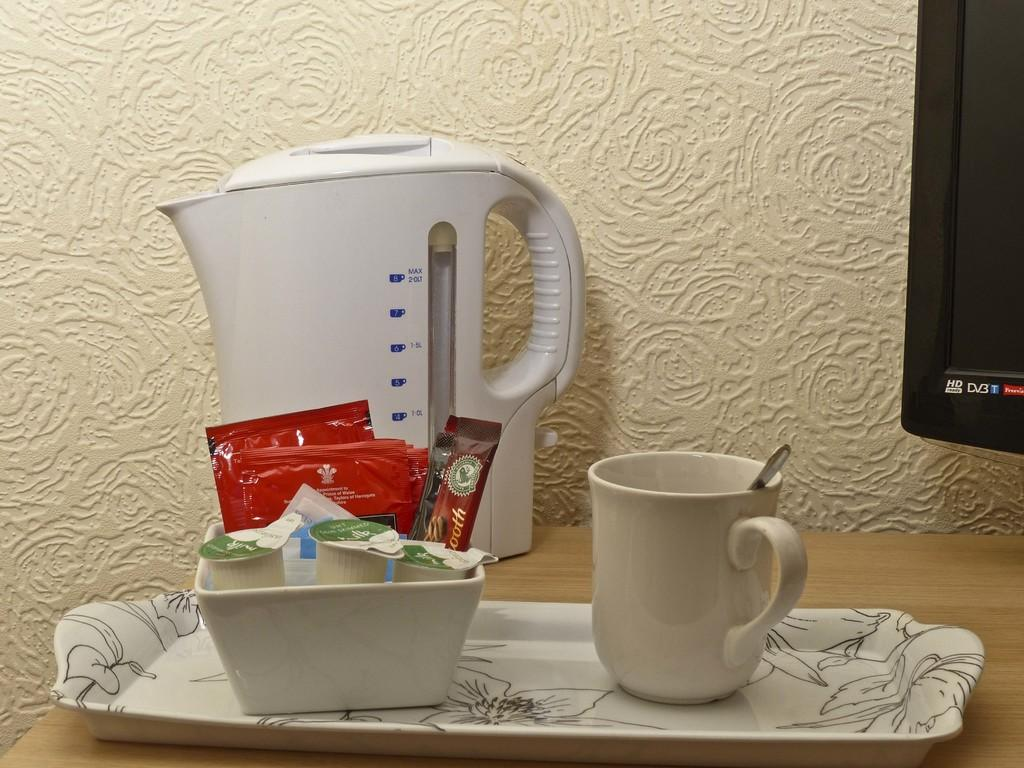<image>
Provide a brief description of the given image. An HD TV sits to the side of a breakfast array. 